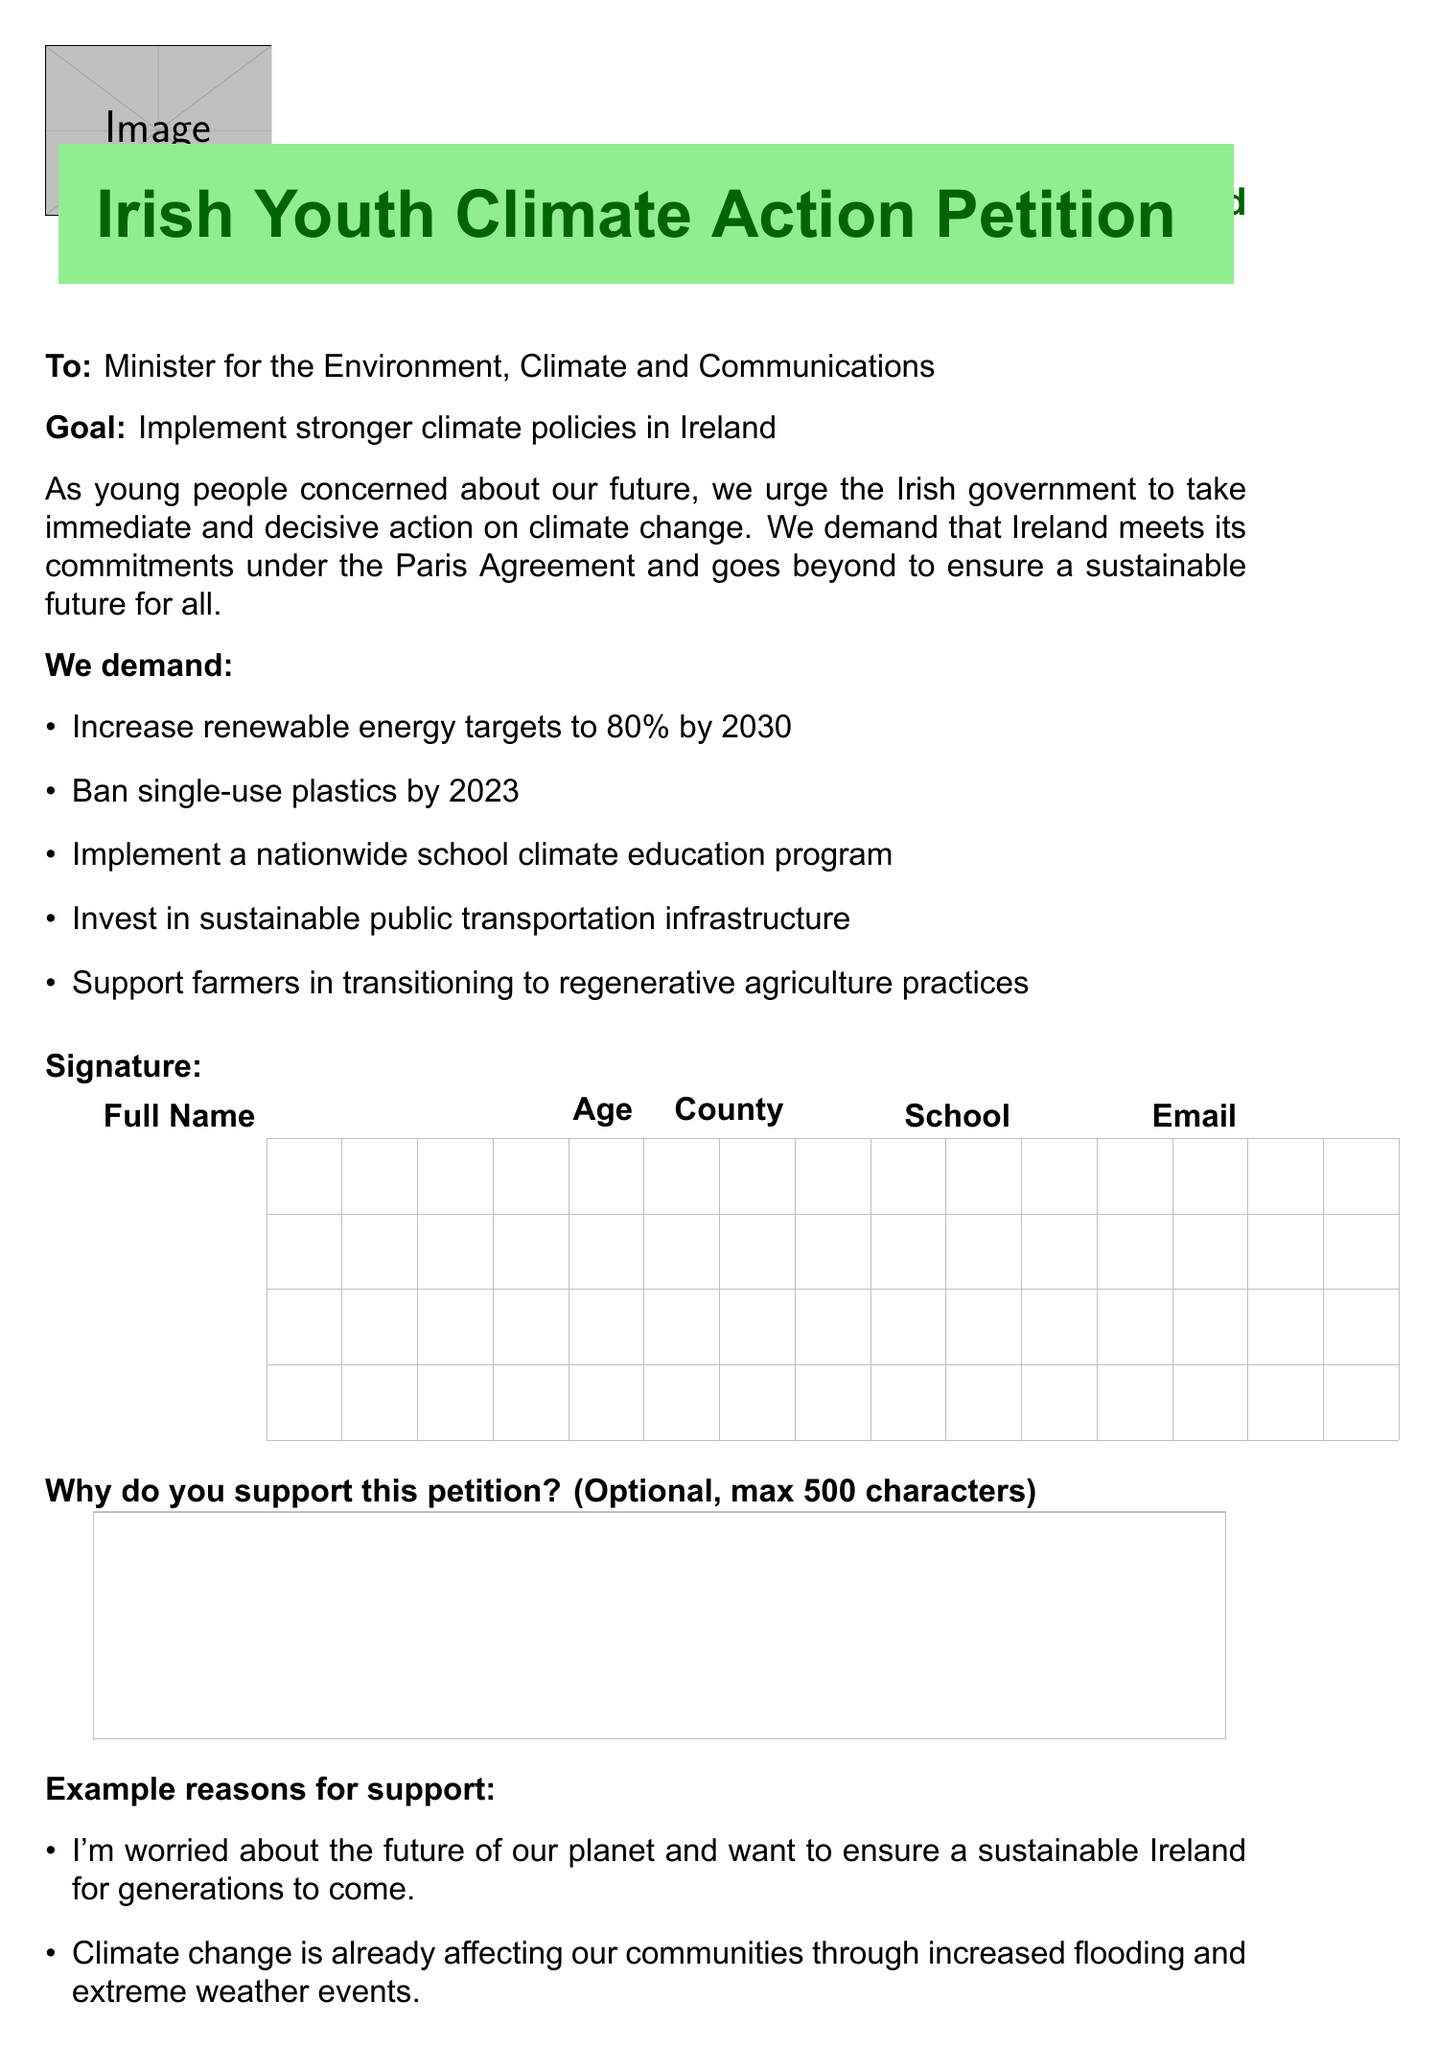What is the title of the petition? The title of the petition is stated at the top of the document.
Answer: Irish Youth Climate Action Petition Who is the petition directed to? The recipient of the petition is clearly mentioned in the document.
Answer: Minister for the Environment, Climate and Communications What year should single-use plastics be banned by? The document lists the deadline for this demand.
Answer: 2023 What is one of the demands made in the petition? Several demands are listed, and one can be pointed out from the list.
Answer: Increase renewable energy targets to 80% by 2030 What is the maximum length for the reason for support? The document specifies the character limit for this section.
Answer: 500 characters Which organization is associated with the petition? The petition mentions related organizations towards the end.
Answer: Friends of the Earth Ireland What is the privacy notice about? The document includes a section related to personal data protection.
Answer: GDPR regulations How can completed petition forms be submitted? The submission instructions detail how to send the completed forms.
Answer: Email a scanned copy to petitions@greenschoolsireland.org 